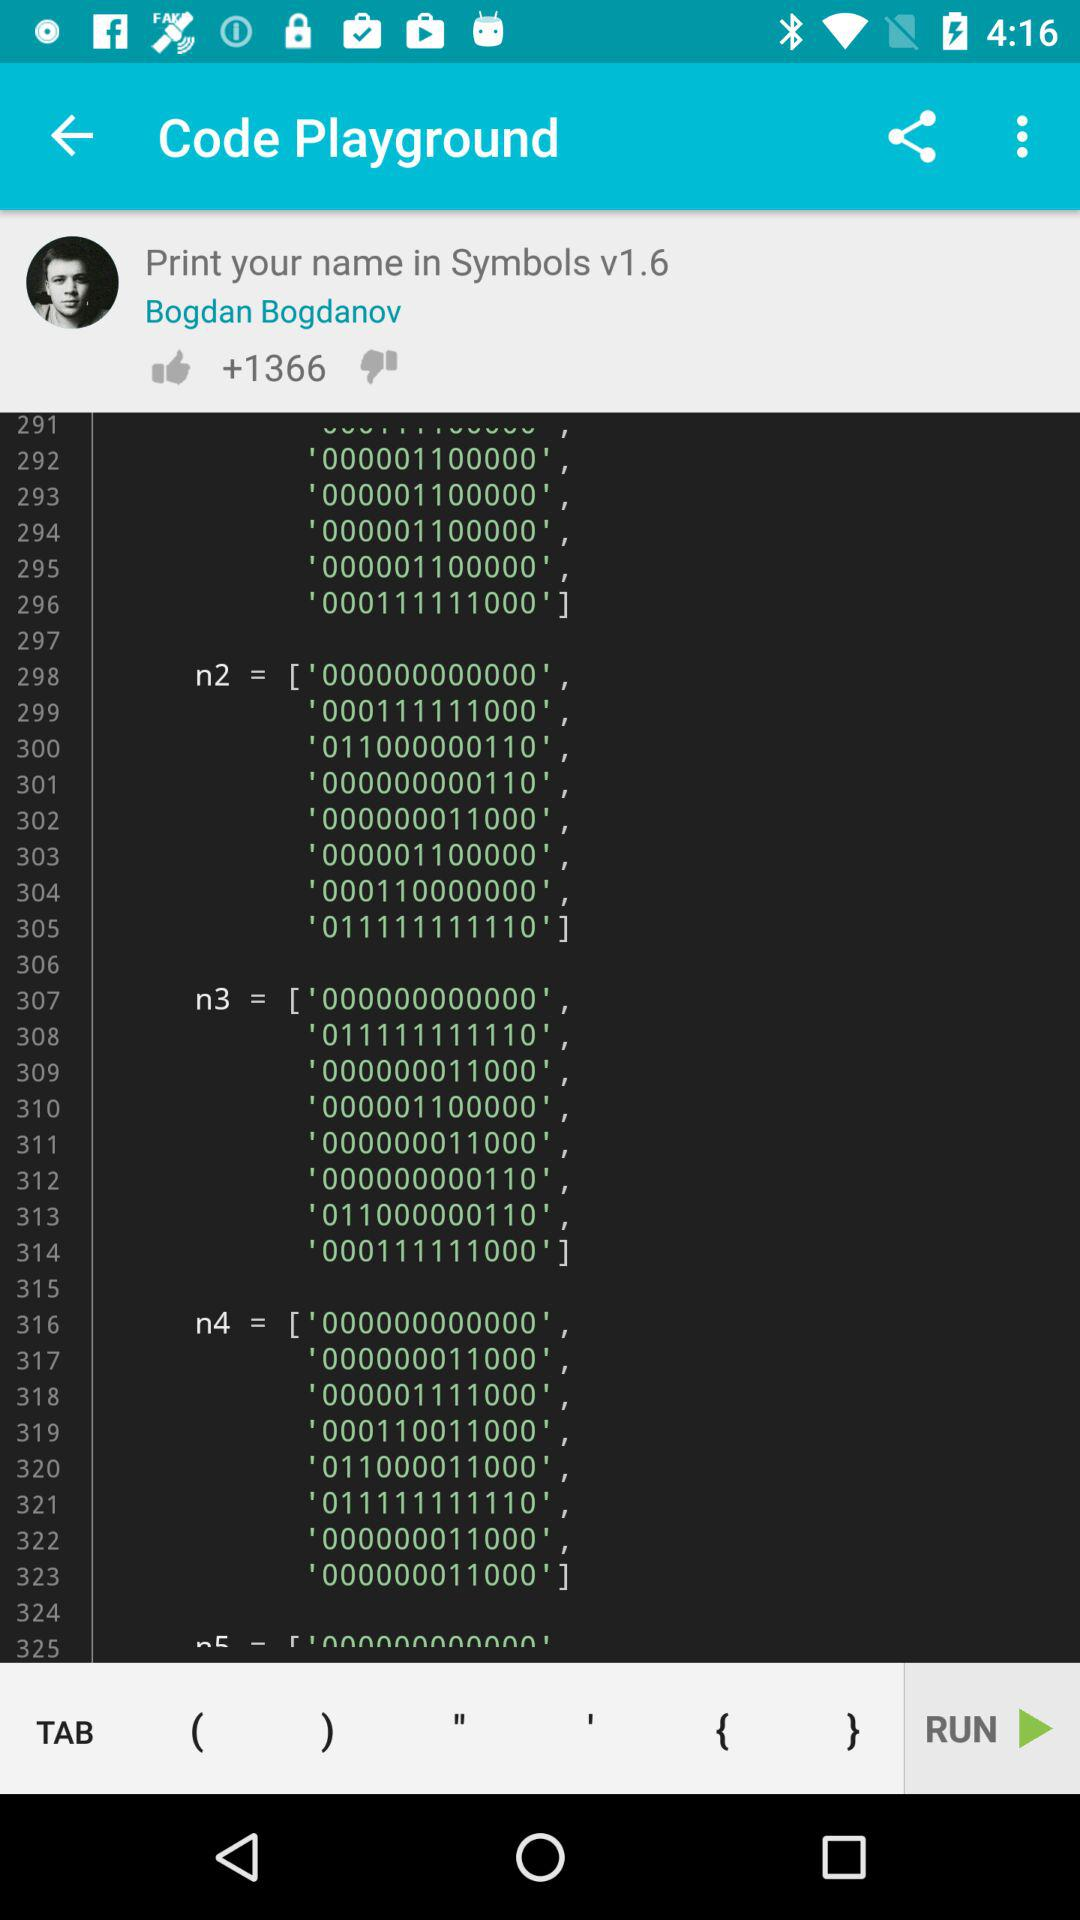What is the user name? The user name is Bogdan Bogdanov. 